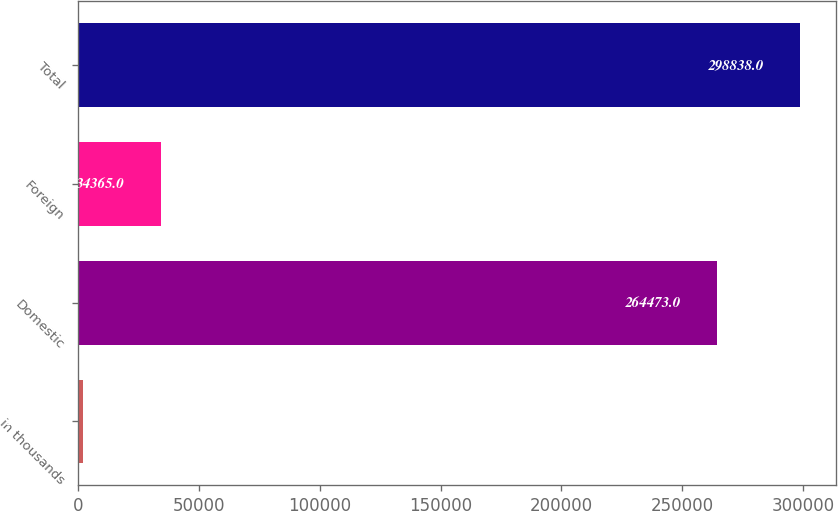Convert chart. <chart><loc_0><loc_0><loc_500><loc_500><bar_chart><fcel>in thousands<fcel>Domestic<fcel>Foreign<fcel>Total<nl><fcel>2014<fcel>264473<fcel>34365<fcel>298838<nl></chart> 